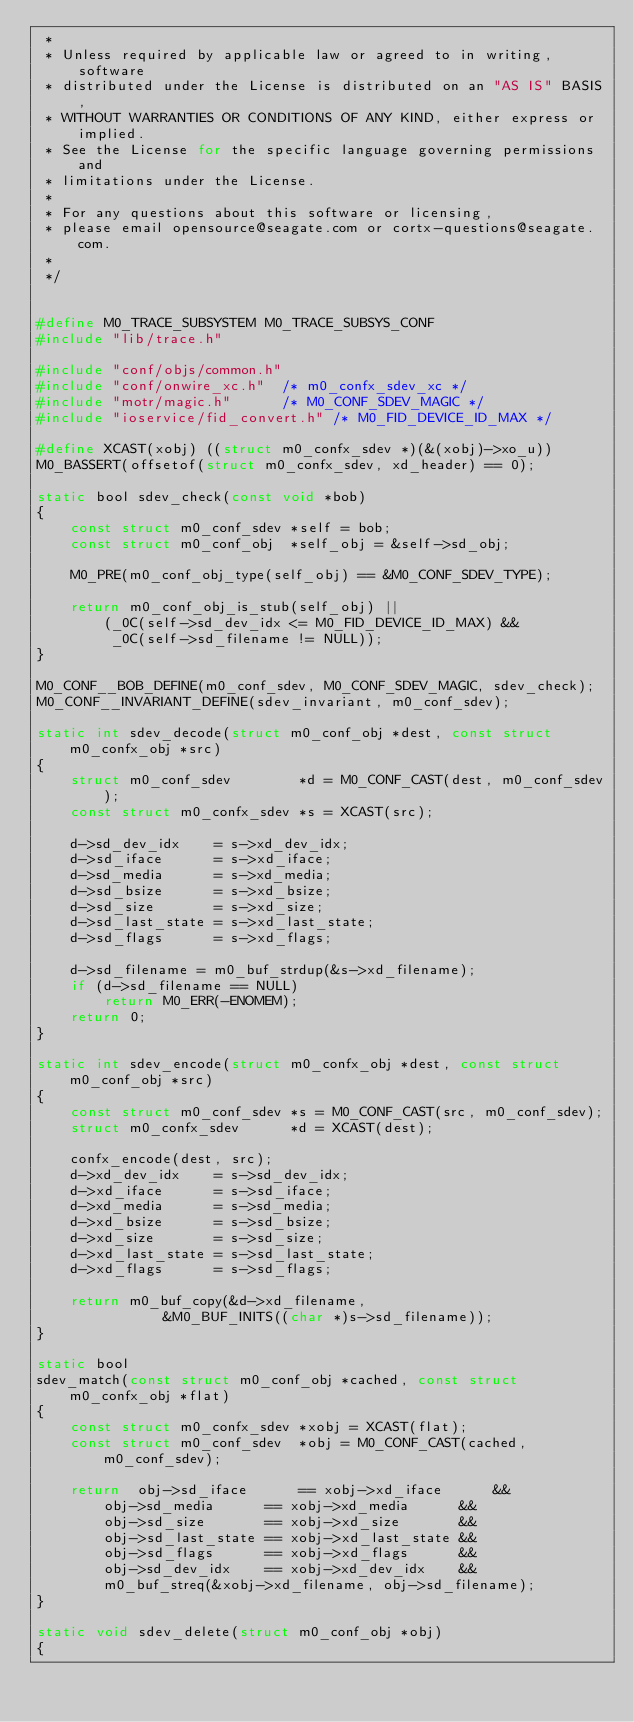<code> <loc_0><loc_0><loc_500><loc_500><_C_> *
 * Unless required by applicable law or agreed to in writing, software
 * distributed under the License is distributed on an "AS IS" BASIS,
 * WITHOUT WARRANTIES OR CONDITIONS OF ANY KIND, either express or implied.
 * See the License for the specific language governing permissions and
 * limitations under the License.
 *
 * For any questions about this software or licensing,
 * please email opensource@seagate.com or cortx-questions@seagate.com.
 *
 */


#define M0_TRACE_SUBSYSTEM M0_TRACE_SUBSYS_CONF
#include "lib/trace.h"

#include "conf/objs/common.h"
#include "conf/onwire_xc.h"  /* m0_confx_sdev_xc */
#include "motr/magic.h"      /* M0_CONF_SDEV_MAGIC */
#include "ioservice/fid_convert.h" /* M0_FID_DEVICE_ID_MAX */

#define XCAST(xobj) ((struct m0_confx_sdev *)(&(xobj)->xo_u))
M0_BASSERT(offsetof(struct m0_confx_sdev, xd_header) == 0);

static bool sdev_check(const void *bob)
{
	const struct m0_conf_sdev *self = bob;
	const struct m0_conf_obj  *self_obj = &self->sd_obj;

	M0_PRE(m0_conf_obj_type(self_obj) == &M0_CONF_SDEV_TYPE);

	return m0_conf_obj_is_stub(self_obj) ||
		(_0C(self->sd_dev_idx <= M0_FID_DEVICE_ID_MAX) &&
		 _0C(self->sd_filename != NULL));
}

M0_CONF__BOB_DEFINE(m0_conf_sdev, M0_CONF_SDEV_MAGIC, sdev_check);
M0_CONF__INVARIANT_DEFINE(sdev_invariant, m0_conf_sdev);

static int sdev_decode(struct m0_conf_obj *dest, const struct m0_confx_obj *src)
{
	struct m0_conf_sdev        *d = M0_CONF_CAST(dest, m0_conf_sdev);
	const struct m0_confx_sdev *s = XCAST(src);

	d->sd_dev_idx    = s->xd_dev_idx;
	d->sd_iface      = s->xd_iface;
	d->sd_media      = s->xd_media;
	d->sd_bsize      = s->xd_bsize;
	d->sd_size       = s->xd_size;
	d->sd_last_state = s->xd_last_state;
	d->sd_flags      = s->xd_flags;

	d->sd_filename = m0_buf_strdup(&s->xd_filename);
	if (d->sd_filename == NULL)
		return M0_ERR(-ENOMEM);
	return 0;
}

static int sdev_encode(struct m0_confx_obj *dest, const struct m0_conf_obj *src)
{
	const struct m0_conf_sdev *s = M0_CONF_CAST(src, m0_conf_sdev);
	struct m0_confx_sdev      *d = XCAST(dest);

	confx_encode(dest, src);
	d->xd_dev_idx    = s->sd_dev_idx;
	d->xd_iface      = s->sd_iface;
	d->xd_media      = s->sd_media;
	d->xd_bsize      = s->sd_bsize;
	d->xd_size       = s->sd_size;
	d->xd_last_state = s->sd_last_state;
	d->xd_flags      = s->sd_flags;

	return m0_buf_copy(&d->xd_filename,
			   &M0_BUF_INITS((char *)s->sd_filename));
}

static bool
sdev_match(const struct m0_conf_obj *cached, const struct m0_confx_obj *flat)
{
	const struct m0_confx_sdev *xobj = XCAST(flat);
	const struct m0_conf_sdev  *obj = M0_CONF_CAST(cached, m0_conf_sdev);

	return  obj->sd_iface      == xobj->xd_iface      &&
		obj->sd_media      == xobj->xd_media      &&
		obj->sd_size       == xobj->xd_size       &&
		obj->sd_last_state == xobj->xd_last_state &&
		obj->sd_flags      == xobj->xd_flags      &&
		obj->sd_dev_idx    == xobj->xd_dev_idx    &&
		m0_buf_streq(&xobj->xd_filename, obj->sd_filename);
}

static void sdev_delete(struct m0_conf_obj *obj)
{</code> 